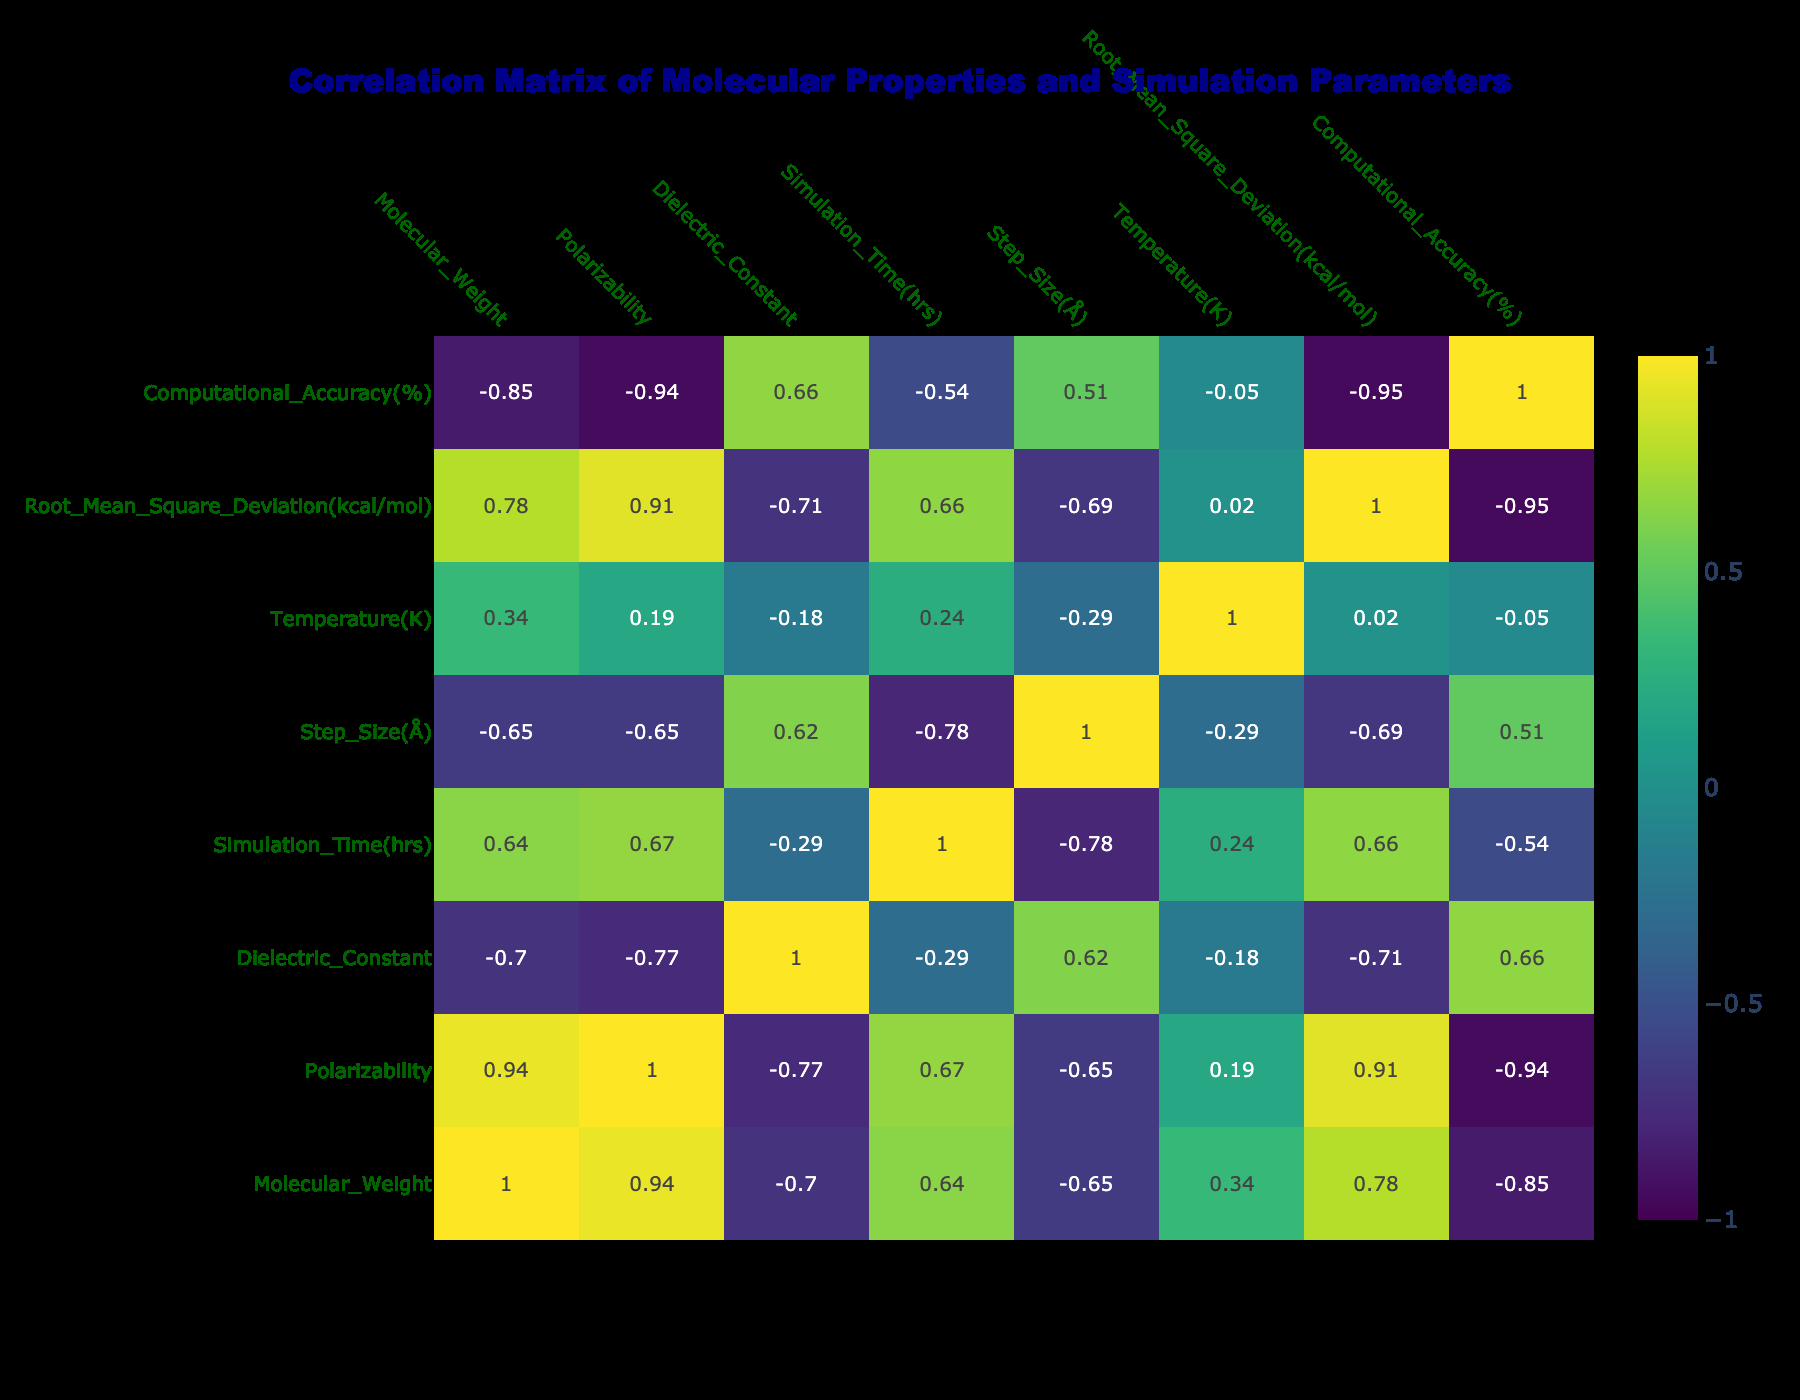What is the computational accuracy for the molecule with the highest molecular weight? The data shows that the molecule with the highest molecular weight is 72.149 with a computational accuracy of 89%.
Answer: 89% What is the step size of the molecule with the lowest polarizability? The data indicates that the molecule with the lowest polarizability is 1.0, which corresponds to a step size of 0.1 Å.
Answer: 0.1 Å Is there a correlation between simulation time and computational accuracy? Looking at the correlation matrix, we determine that simulation time has a correlation coefficient of approximately -0.54 with computational accuracy, indicating a negative correlation.
Answer: Yes What is the average root mean square deviation for molecules with a dielectric constant above 30? To find this, we first filter for the dielectric constants above 30, which are 34.6. The root mean square deviation for this single data point is 0.008, hence the average is also 0.008.
Answer: 0.008 Does increasing the temperature generally lead to a lower computational accuracy? The correlation matrix shows a negative correlation of approximately -0.47 between temperature and computational accuracy, which suggests that as temperature increases, computational accuracy tends to decrease.
Answer: Yes What is the difference in computational accuracy between the molecules with the highest and lowest polarizability? The highest polarizability is 5.0 with an accuracy of 89%, and the lowest is 1.0 with an accuracy of 99%. The difference is 99% - 89% = 10%.
Answer: 10% What is the average molecular weight of the molecules with computational accuracy greater than or equal to 95%? To calculate this, we first identify the molecular weights of the corresponding entries: 18.01528, 44.0095, 46.06844, and 18.01528. The sum is 126.11302, and there are 4 data points, so the average is 126.11302 / 4 = 31.528255.
Answer: 31.53 Is there a molecule for which the root mean square deviation is less than 0.004? By examining the data, we see that the root mean square deviations for the given molecules are 0.003, 0.005, 0.004, 0.006, 0.002, 0.007, 0.006, and 0.008. The value 0.002 is indeed less than 0.004, so the answer is yes.
Answer: Yes What are the simulation times for molecules with a dielectric constant of 21 or lower? The relevant molecules with a dielectric constant fitting this criterion are those with values of 21.0 and 19.0, running for 48 hrs and 72 hrs, respectively. Thus, the simulation times are 48 and 72 hours.
Answer: 48 hrs, 72 hrs 